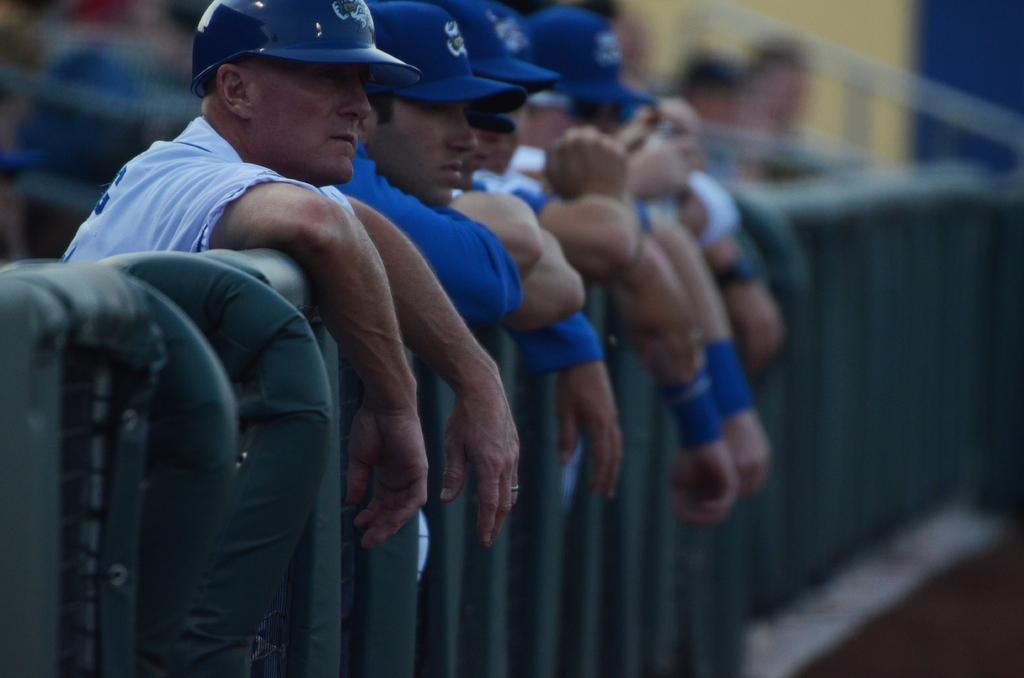What can be seen in the image? There is a group of people in the image. What are the people wearing on their heads? The people are wearing blue caps. Where are the people standing in relation to the railing? The people are standing behind the railing. Can you describe the background of the image? The background of the image is blurry. Are there any tents visible in the image? No, there are no tents present in the image. How many pigs are accompanying the group of people in the image? There are no pigs present in the image. 